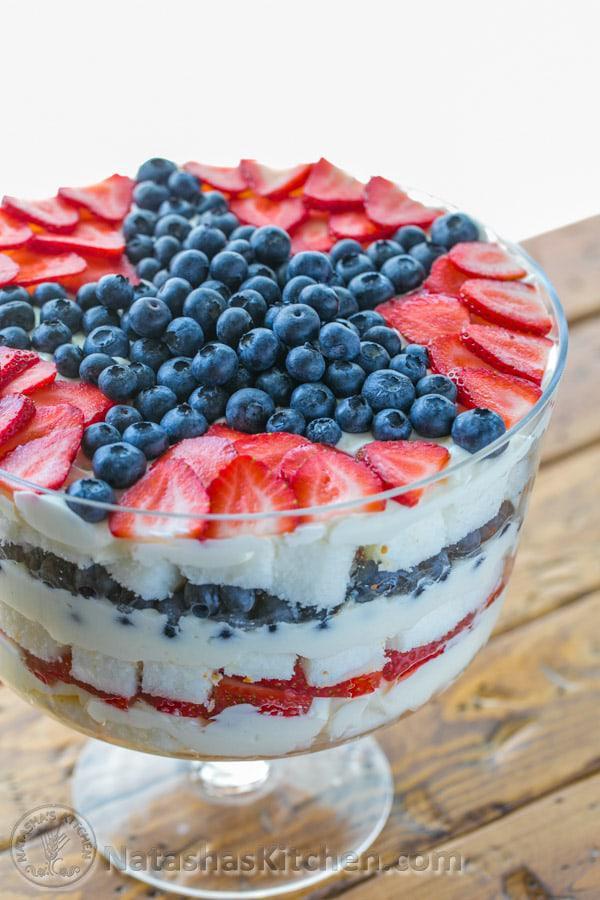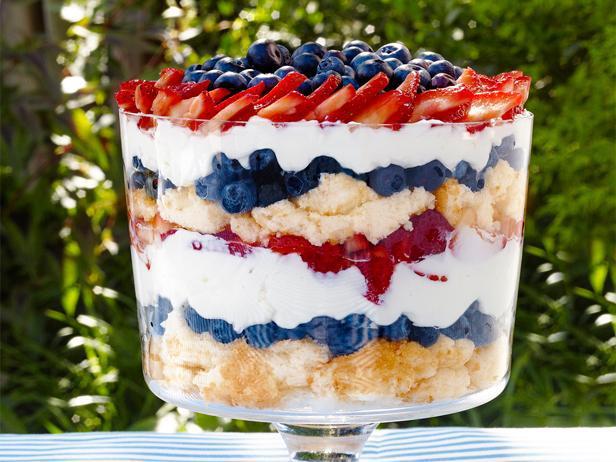The first image is the image on the left, the second image is the image on the right. Given the left and right images, does the statement "A dessert is garnished with blueberries, strawberry slices, and a few strawberries with their leafy green caps intact." hold true? Answer yes or no. No. The first image is the image on the left, the second image is the image on the right. Evaluate the accuracy of this statement regarding the images: "There is an eating utensil next to a bowl of dessert.". Is it true? Answer yes or no. No. 